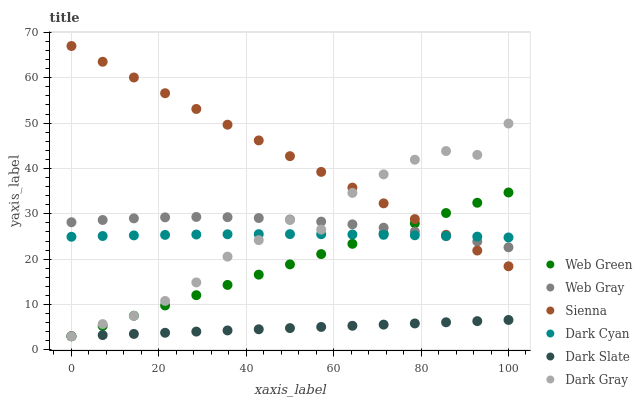Does Dark Slate have the minimum area under the curve?
Answer yes or no. Yes. Does Sienna have the maximum area under the curve?
Answer yes or no. Yes. Does Web Gray have the minimum area under the curve?
Answer yes or no. No. Does Web Gray have the maximum area under the curve?
Answer yes or no. No. Is Dark Slate the smoothest?
Answer yes or no. Yes. Is Dark Gray the roughest?
Answer yes or no. Yes. Is Web Gray the smoothest?
Answer yes or no. No. Is Web Gray the roughest?
Answer yes or no. No. Does Dark Gray have the lowest value?
Answer yes or no. Yes. Does Web Gray have the lowest value?
Answer yes or no. No. Does Sienna have the highest value?
Answer yes or no. Yes. Does Web Gray have the highest value?
Answer yes or no. No. Is Dark Slate less than Dark Cyan?
Answer yes or no. Yes. Is Sienna greater than Dark Slate?
Answer yes or no. Yes. Does Web Gray intersect Dark Gray?
Answer yes or no. Yes. Is Web Gray less than Dark Gray?
Answer yes or no. No. Is Web Gray greater than Dark Gray?
Answer yes or no. No. Does Dark Slate intersect Dark Cyan?
Answer yes or no. No. 